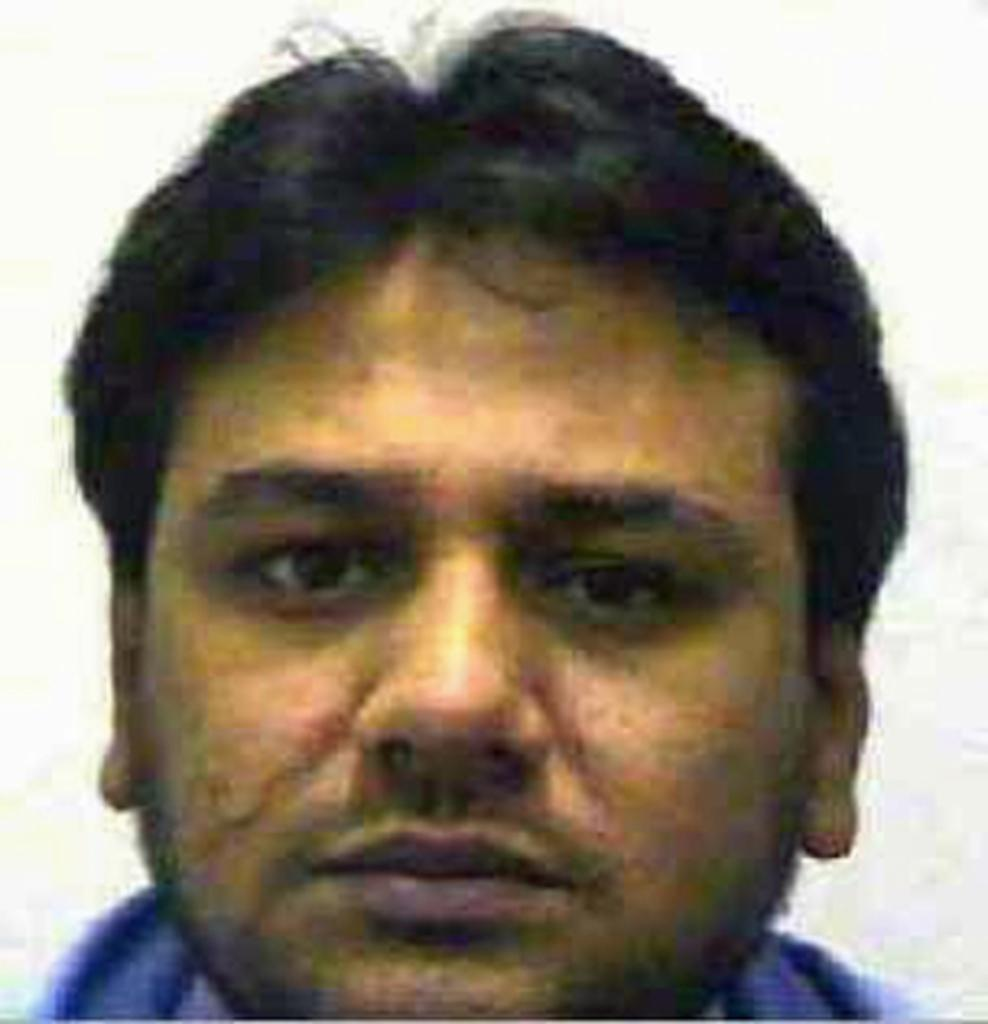What is the main subject of the image? The main subject of the image is a man. What can be observed about the man's attire? The man is wearing clothes. What color is the background of the image? The background of the image is white. What type of twig is the man holding in the image? There is no twig present in the image. What might have surprised the man in the image? The image does not provide any information about the man's emotions or any surprising events, so we cannot determine what might have surprised him. 